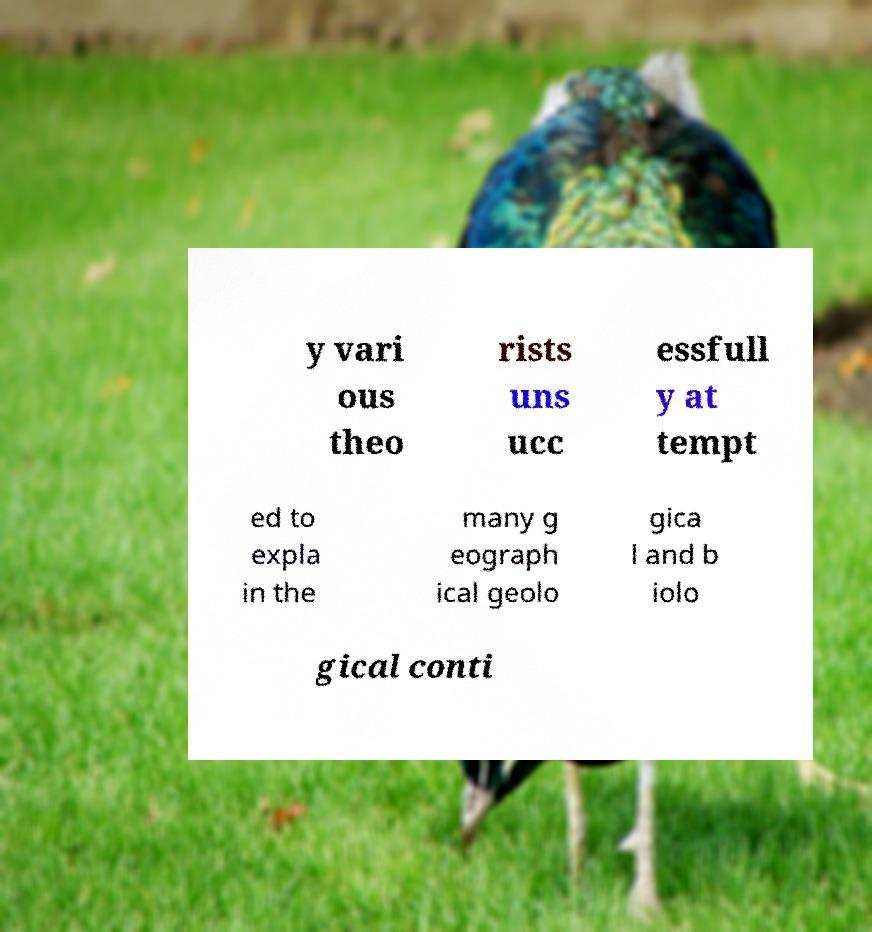Can you read and provide the text displayed in the image?This photo seems to have some interesting text. Can you extract and type it out for me? y vari ous theo rists uns ucc essfull y at tempt ed to expla in the many g eograph ical geolo gica l and b iolo gical conti 